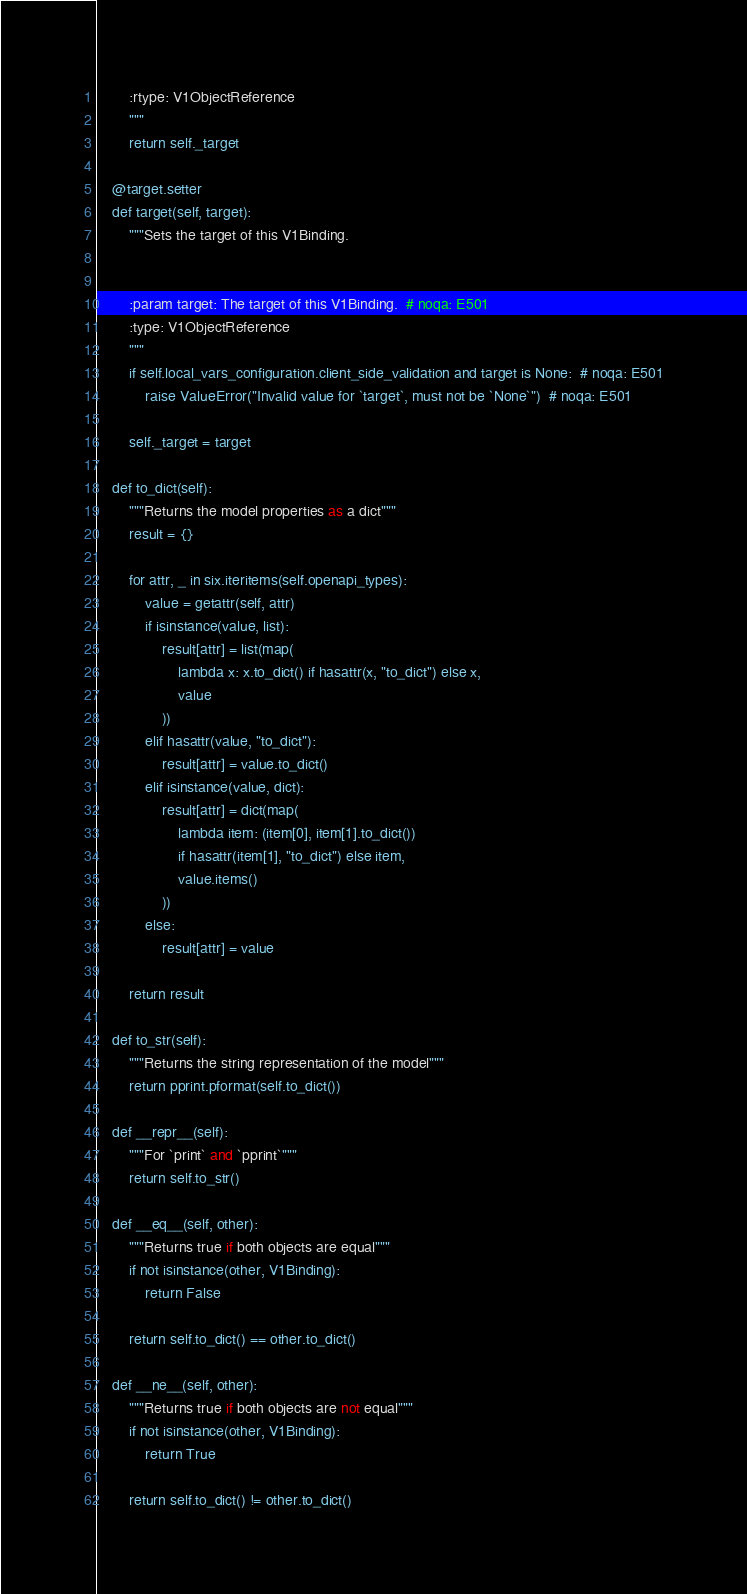Convert code to text. <code><loc_0><loc_0><loc_500><loc_500><_Python_>        :rtype: V1ObjectReference
        """
        return self._target

    @target.setter
    def target(self, target):
        """Sets the target of this V1Binding.


        :param target: The target of this V1Binding.  # noqa: E501
        :type: V1ObjectReference
        """
        if self.local_vars_configuration.client_side_validation and target is None:  # noqa: E501
            raise ValueError("Invalid value for `target`, must not be `None`")  # noqa: E501

        self._target = target

    def to_dict(self):
        """Returns the model properties as a dict"""
        result = {}

        for attr, _ in six.iteritems(self.openapi_types):
            value = getattr(self, attr)
            if isinstance(value, list):
                result[attr] = list(map(
                    lambda x: x.to_dict() if hasattr(x, "to_dict") else x,
                    value
                ))
            elif hasattr(value, "to_dict"):
                result[attr] = value.to_dict()
            elif isinstance(value, dict):
                result[attr] = dict(map(
                    lambda item: (item[0], item[1].to_dict())
                    if hasattr(item[1], "to_dict") else item,
                    value.items()
                ))
            else:
                result[attr] = value

        return result

    def to_str(self):
        """Returns the string representation of the model"""
        return pprint.pformat(self.to_dict())

    def __repr__(self):
        """For `print` and `pprint`"""
        return self.to_str()

    def __eq__(self, other):
        """Returns true if both objects are equal"""
        if not isinstance(other, V1Binding):
            return False

        return self.to_dict() == other.to_dict()

    def __ne__(self, other):
        """Returns true if both objects are not equal"""
        if not isinstance(other, V1Binding):
            return True

        return self.to_dict() != other.to_dict()
</code> 